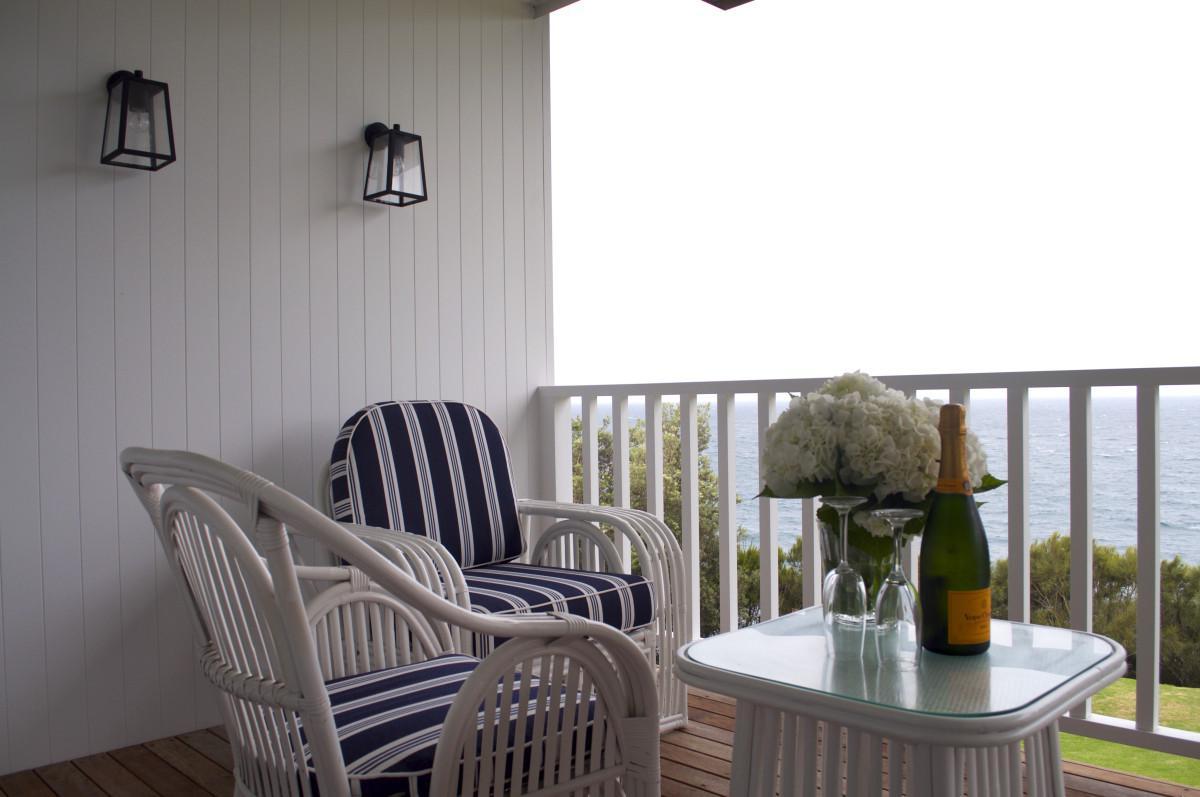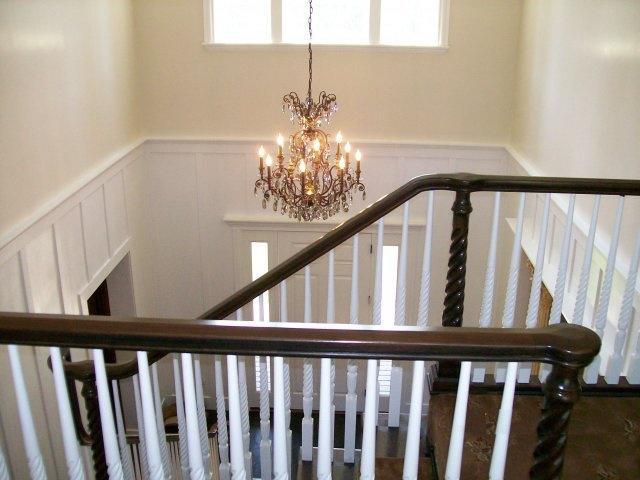The first image is the image on the left, the second image is the image on the right. Considering the images on both sides, is "One set of stairs has partly silver colored railings." valid? Answer yes or no. No. 